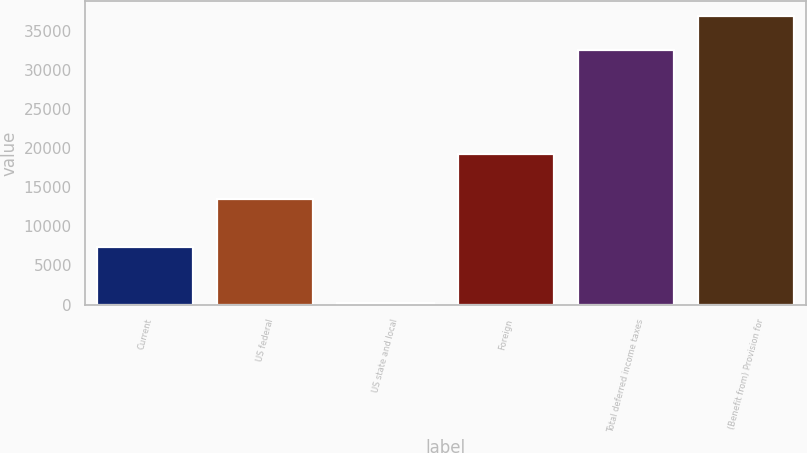Convert chart to OTSL. <chart><loc_0><loc_0><loc_500><loc_500><bar_chart><fcel>Current<fcel>US federal<fcel>US state and local<fcel>Foreign<fcel>Total deferred income taxes<fcel>(Benefit from) Provision for<nl><fcel>7327<fcel>13530<fcel>195<fcel>19188<fcel>32523<fcel>36908<nl></chart> 